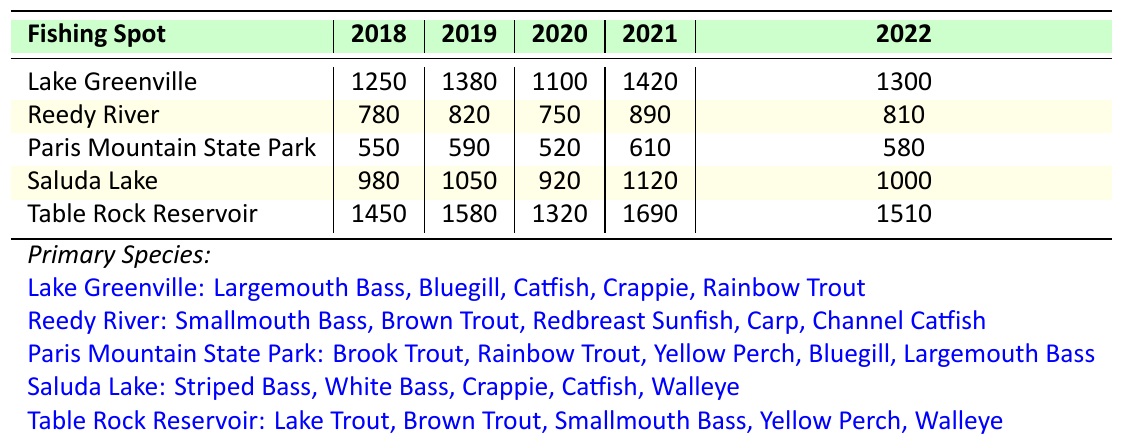What was the highest annual fish catch recorded at Table Rock Reservoir? The table shows that the catches for Table Rock Reservoir in the years 2018 to 2022 are 1450, 1580, 1320, 1690, and 1510. The highest catch is 1690 in 2021.
Answer: 1690 Which fishing spot had the lowest catch in 2019? The table indicates that the catches in 2019 for each fishing spot are: Lake Greenville (1380), Reedy River (820), Paris Mountain State Park (590), Saluda Lake (1050), and Table Rock Reservoir (1580). The lowest catch was at Paris Mountain State Park with 590.
Answer: Paris Mountain State Park What is the total fish catch for Lake Greenville from 2018 to 2022? To find this, we sum the catches: 1250 + 1380 + 1100 + 1420 + 1300 = 6450.
Answer: 6450 Did any fishing spot have a catch of over 1500 in 2022? Checking the 2022 values, the catches are Lake Greenville (1300), Reedy River (810), Paris Mountain State Park (580), Saluda Lake (1000), and Table Rock Reservoir (1510). The only spot with over 1500 is Table Rock Reservoir, which has 1510.
Answer: Yes What was the average annual catch for the Reedy River from 2018 to 2022? We take the catches for Reedy River: 780, 820, 750, 890, and 810. The total is 4050, and averaging over 5 years gives us 4050 / 5 = 810.
Answer: 810 Which fishing spot experienced the most significant increase in fish catch from 2020 to 2021? We calculate the difference in catches for each spot: Lake Greenville (1420 - 1100 = 320), Reedy River (890 - 750 = 140), Paris Mountain State Park (610 - 520 = 90), Saluda Lake (1120 - 920 = 200), and Table Rock Reservoir (1690 - 1320 = 370). The largest increase is 370 at Table Rock Reservoir.
Answer: Table Rock Reservoir How many species are reported for fishing at Paris Mountain State Park? The table specifies that Paris Mountain State Park has 5 primary species listed: Brook Trout, Rainbow Trout, Yellow Perch, Bluegill, and Largemouth Bass.
Answer: 5 Was the total catch for Saluda Lake in 2020 greater than the total catch for Reedy River in 2020? The catch for Saluda Lake in 2020 is 920, and for Reedy River, it is 750. Since 920 is greater than 750, Saluda Lake's catch was greater.
Answer: Yes What year saw the highest total fish catch across all fishing spots combined? To find this, we sum the annual catches for each year: 2018 (1250 + 780 + 550 + 980 + 1450 = 4010), 2019 (1380 + 820 + 590 + 1050 + 1580 = 4420), 2020 (1100 + 750 + 520 + 920 + 1320 = 3560), 2021 (1420 + 890 + 610 + 1120 + 1690 = 4830), and 2022 (1300 + 810 + 580 + 1000 + 1510 = 4200). The highest total is 4830 in 2021.
Answer: 2021 What was the trend in fish catch for Lake Greenville from 2018 to 2022? The catches for Lake Greenville during these years are 1250, 1380, 1100, 1420, and 1300. The trend shows an increase from 2018 to 2019, then a decrease in 2020, followed by an increase in 2021, and a slight decrease in 2022. The overall pattern is somewhat fluctuating.
Answer: Fluctuating 